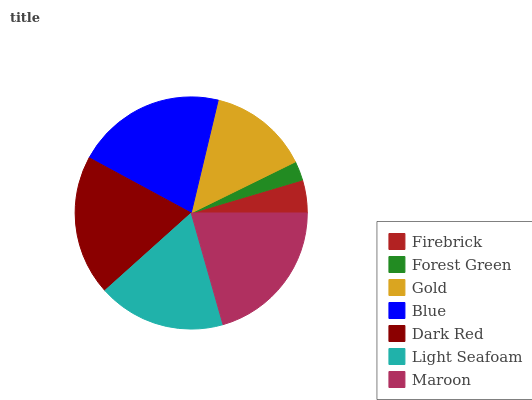Is Forest Green the minimum?
Answer yes or no. Yes. Is Blue the maximum?
Answer yes or no. Yes. Is Gold the minimum?
Answer yes or no. No. Is Gold the maximum?
Answer yes or no. No. Is Gold greater than Forest Green?
Answer yes or no. Yes. Is Forest Green less than Gold?
Answer yes or no. Yes. Is Forest Green greater than Gold?
Answer yes or no. No. Is Gold less than Forest Green?
Answer yes or no. No. Is Light Seafoam the high median?
Answer yes or no. Yes. Is Light Seafoam the low median?
Answer yes or no. Yes. Is Firebrick the high median?
Answer yes or no. No. Is Dark Red the low median?
Answer yes or no. No. 